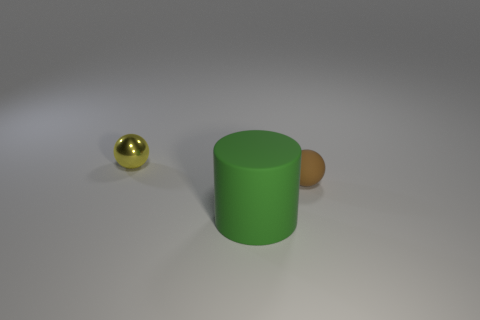Add 3 brown matte objects. How many objects exist? 6 Subtract all balls. How many objects are left? 1 Add 2 brown matte things. How many brown matte things are left? 3 Add 2 tiny yellow metallic balls. How many tiny yellow metallic balls exist? 3 Subtract 0 red balls. How many objects are left? 3 Subtract all tiny brown things. Subtract all yellow shiny objects. How many objects are left? 1 